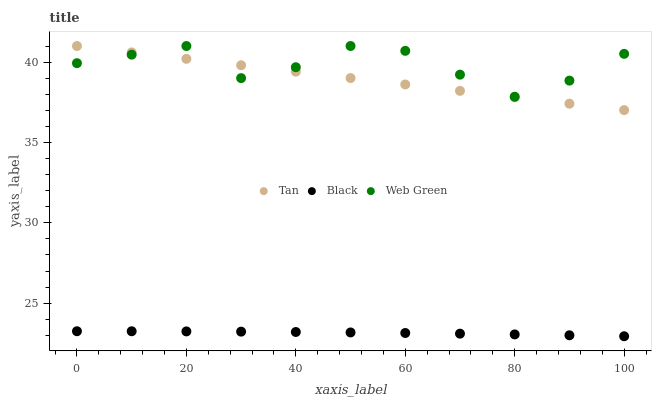Does Black have the minimum area under the curve?
Answer yes or no. Yes. Does Web Green have the maximum area under the curve?
Answer yes or no. Yes. Does Web Green have the minimum area under the curve?
Answer yes or no. No. Does Black have the maximum area under the curve?
Answer yes or no. No. Is Tan the smoothest?
Answer yes or no. Yes. Is Web Green the roughest?
Answer yes or no. Yes. Is Black the smoothest?
Answer yes or no. No. Is Black the roughest?
Answer yes or no. No. Does Black have the lowest value?
Answer yes or no. Yes. Does Web Green have the lowest value?
Answer yes or no. No. Does Web Green have the highest value?
Answer yes or no. Yes. Does Black have the highest value?
Answer yes or no. No. Is Black less than Web Green?
Answer yes or no. Yes. Is Web Green greater than Black?
Answer yes or no. Yes. Does Tan intersect Web Green?
Answer yes or no. Yes. Is Tan less than Web Green?
Answer yes or no. No. Is Tan greater than Web Green?
Answer yes or no. No. Does Black intersect Web Green?
Answer yes or no. No. 